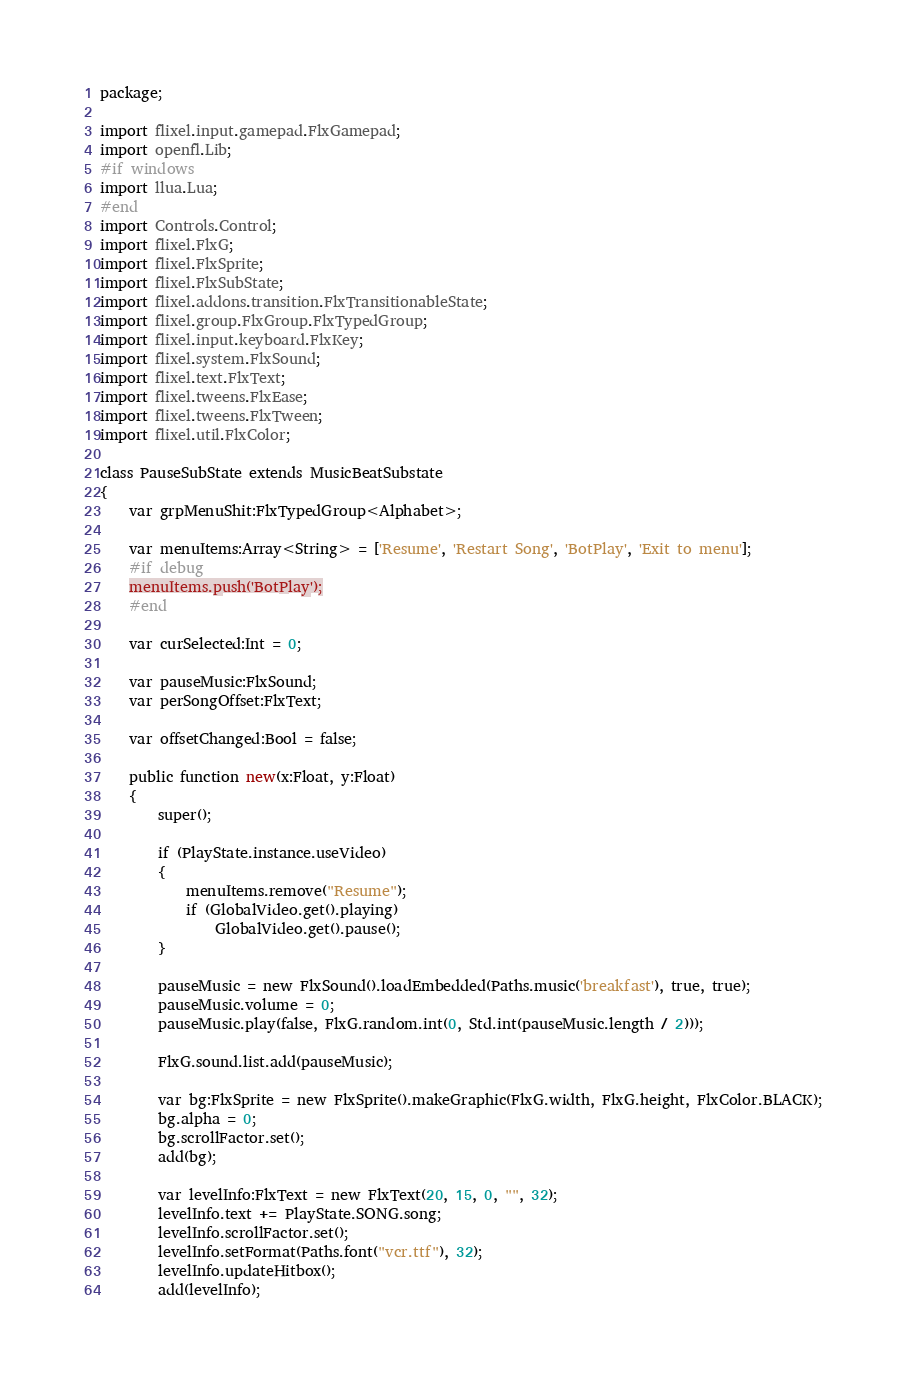<code> <loc_0><loc_0><loc_500><loc_500><_Haxe_>package;

import flixel.input.gamepad.FlxGamepad;
import openfl.Lib;
#if windows
import llua.Lua;
#end
import Controls.Control;
import flixel.FlxG;
import flixel.FlxSprite;
import flixel.FlxSubState;
import flixel.addons.transition.FlxTransitionableState;
import flixel.group.FlxGroup.FlxTypedGroup;
import flixel.input.keyboard.FlxKey;
import flixel.system.FlxSound;
import flixel.text.FlxText;
import flixel.tweens.FlxEase;
import flixel.tweens.FlxTween;
import flixel.util.FlxColor;

class PauseSubState extends MusicBeatSubstate
{
	var grpMenuShit:FlxTypedGroup<Alphabet>;

	var menuItems:Array<String> = ['Resume', 'Restart Song', 'BotPlay', 'Exit to menu'];
	#if debug
	menuItems.push('BotPlay');
	#end

	var curSelected:Int = 0;

	var pauseMusic:FlxSound;
	var perSongOffset:FlxText;
	
	var offsetChanged:Bool = false;

	public function new(x:Float, y:Float)
	{
		super();

		if (PlayState.instance.useVideo)
		{
			menuItems.remove("Resume");
			if (GlobalVideo.get().playing)
				GlobalVideo.get().pause();
		}

		pauseMusic = new FlxSound().loadEmbedded(Paths.music('breakfast'), true, true);
		pauseMusic.volume = 0;
		pauseMusic.play(false, FlxG.random.int(0, Std.int(pauseMusic.length / 2)));

		FlxG.sound.list.add(pauseMusic);

		var bg:FlxSprite = new FlxSprite().makeGraphic(FlxG.width, FlxG.height, FlxColor.BLACK);
		bg.alpha = 0;
		bg.scrollFactor.set();
		add(bg);

		var levelInfo:FlxText = new FlxText(20, 15, 0, "", 32);
		levelInfo.text += PlayState.SONG.song;
		levelInfo.scrollFactor.set();
		levelInfo.setFormat(Paths.font("vcr.ttf"), 32);
		levelInfo.updateHitbox();
		add(levelInfo);
</code> 